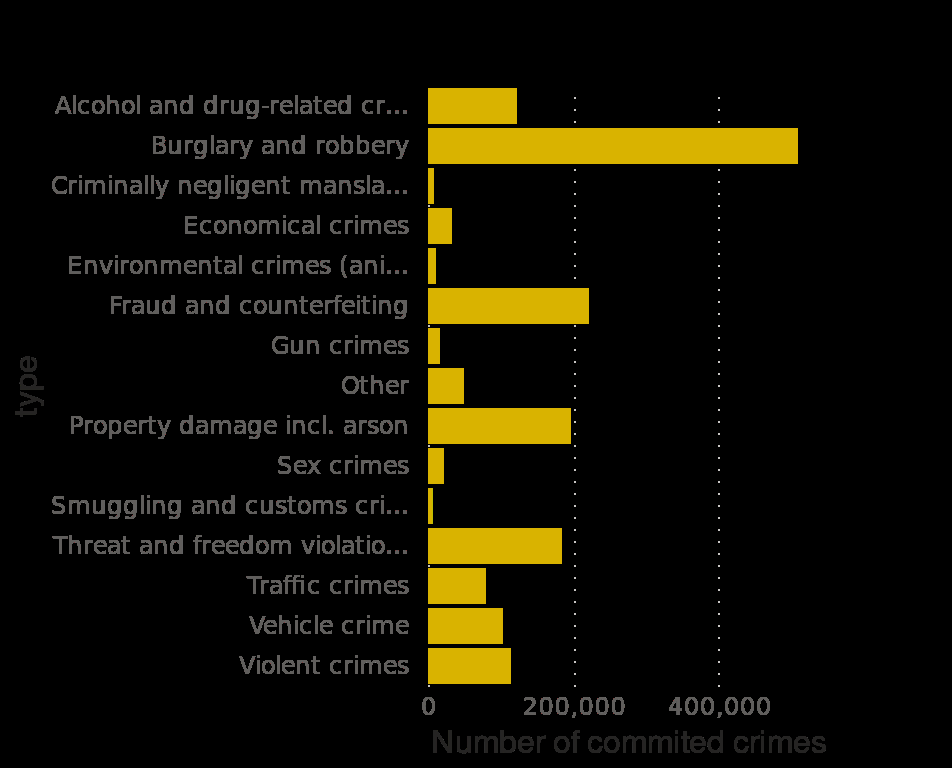<image>
What is the range of the x-axis in the bar graph? The range of the x-axis in the bar graph is from 0 to 400,000. 